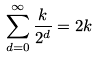<formula> <loc_0><loc_0><loc_500><loc_500>\sum _ { d = 0 } ^ { \infty } \frac { k } { 2 ^ { d } } = 2 k</formula> 